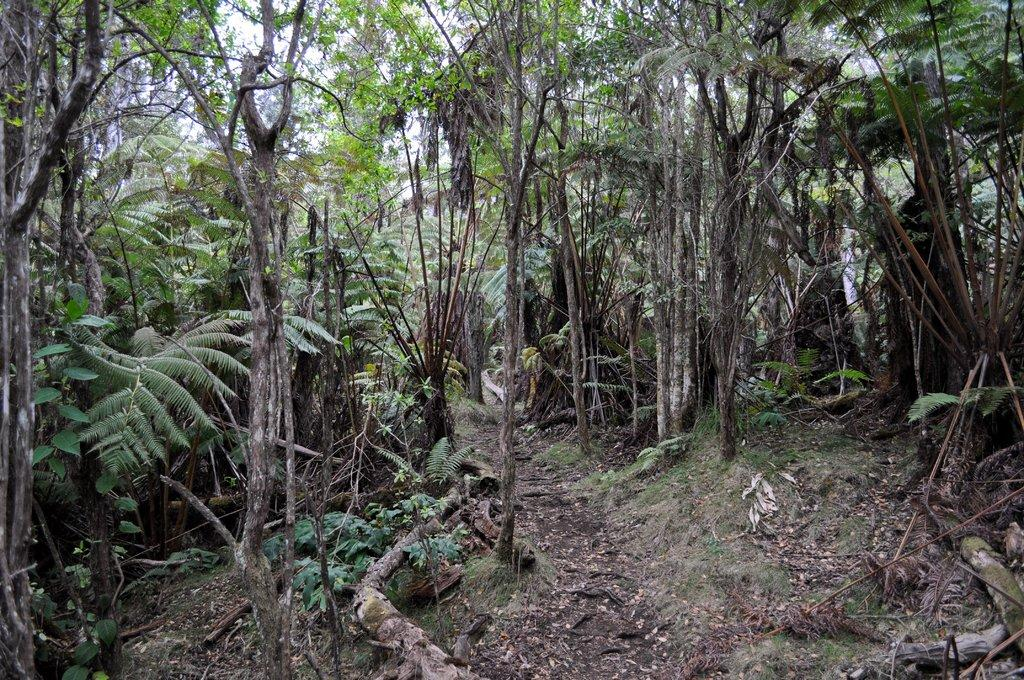What type of natural environment is depicted in the image? The image contains a forest. What is the condition of the forest floor? The forest has a muddy surface. What types of vegetation can be found in the forest? There are plants and trees in the forest. What part of the sky can be seen through the trees? The sky is partially visible through the trees. What type of toy can be seen lying on the muddy surface in the image? There is no toy present in the image; it depicts a forest with a muddy surface, plants, trees, and a partially visible sky. 